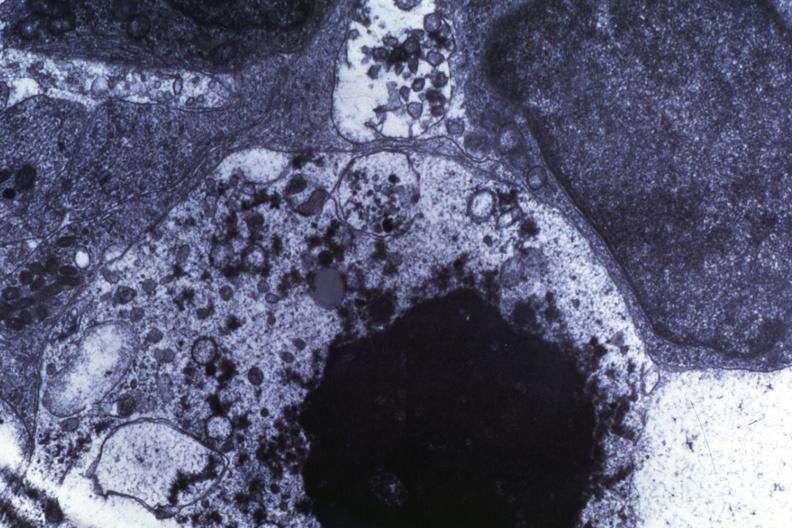what does this image show?
Answer the question using a single word or phrase. Necrosis dr garcia tumors 67 